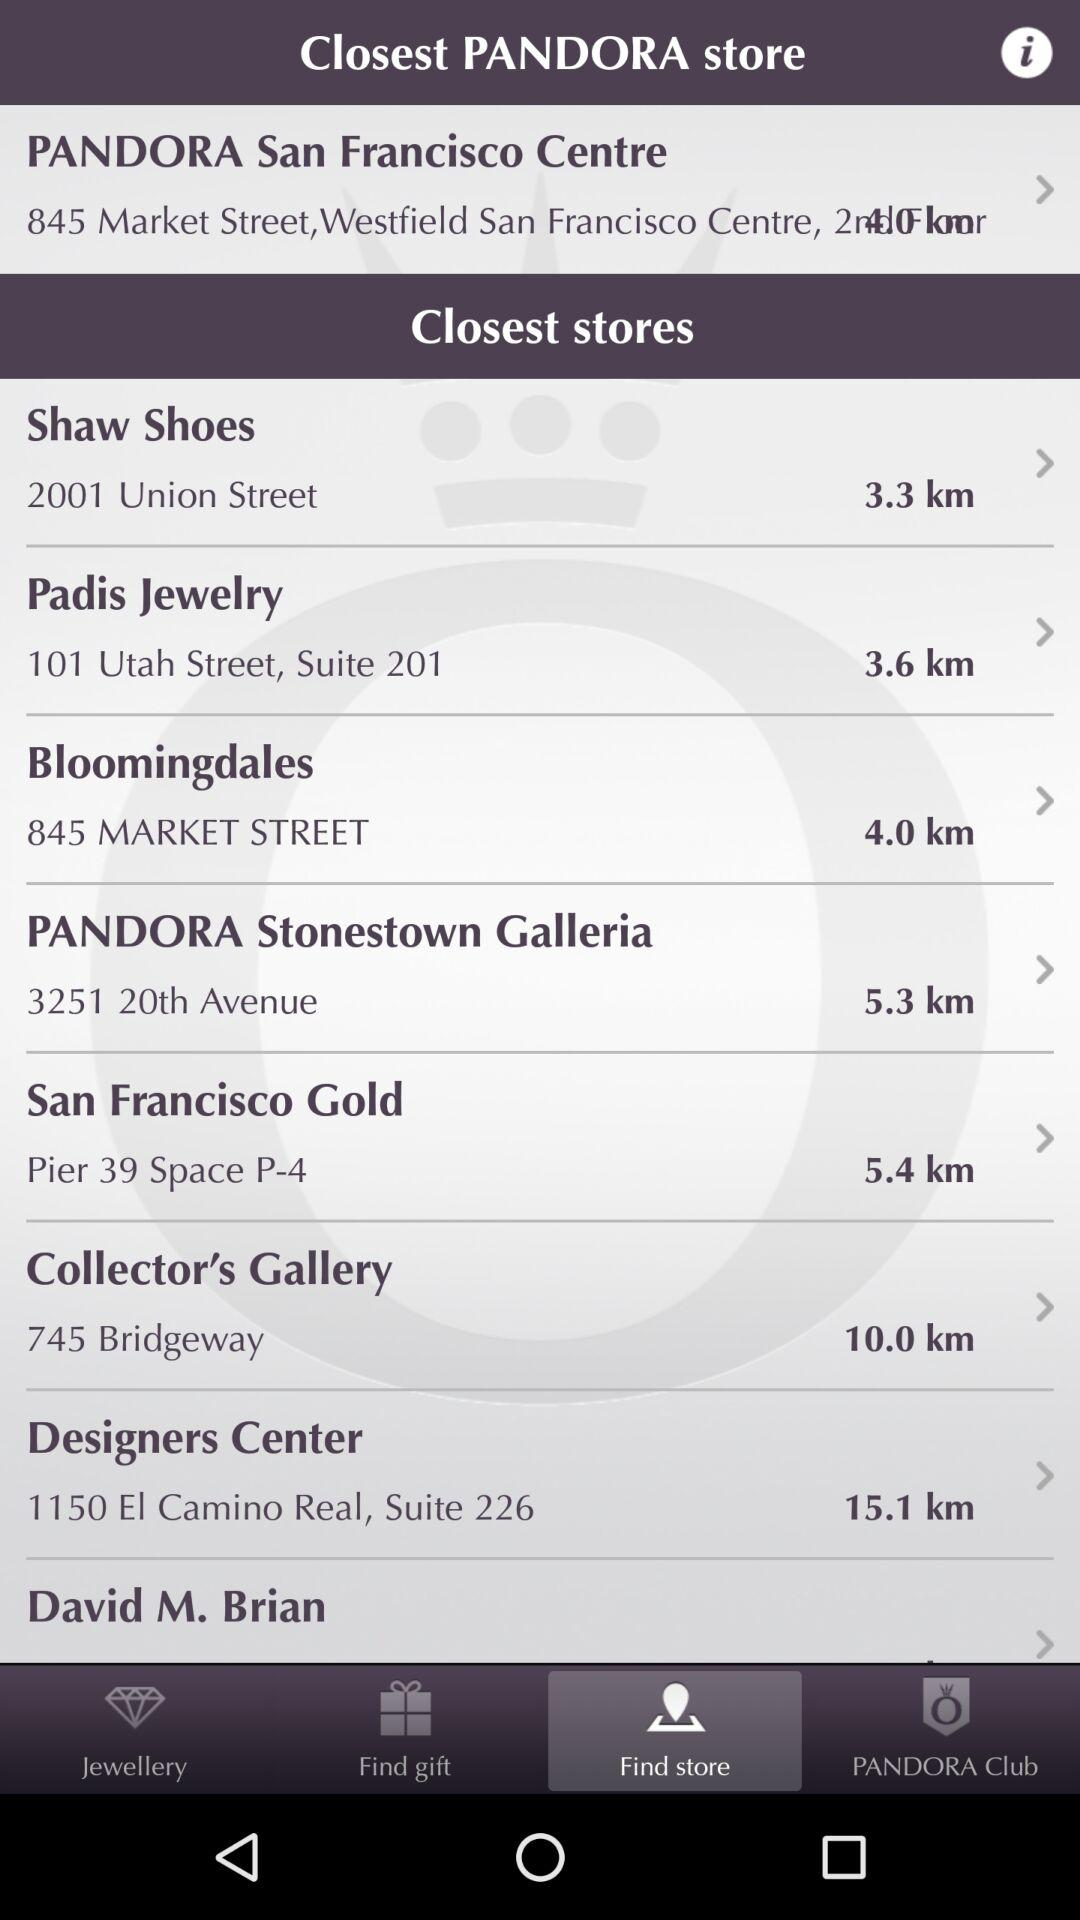Which store is located at 745 Bridgeway? The store located at 745 Bridgeway is "Collector's Gallery". 